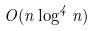<formula> <loc_0><loc_0><loc_500><loc_500>O ( n \log ^ { 4 } n )</formula> 